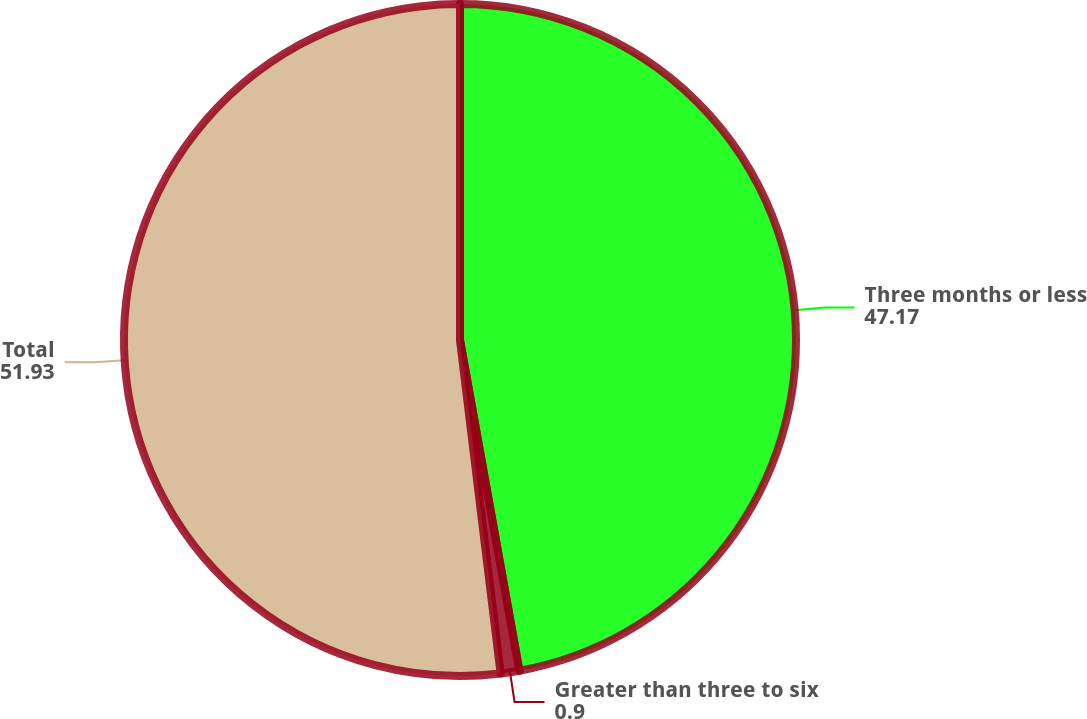<chart> <loc_0><loc_0><loc_500><loc_500><pie_chart><fcel>Three months or less<fcel>Greater than three to six<fcel>Total<nl><fcel>47.17%<fcel>0.9%<fcel>51.93%<nl></chart> 